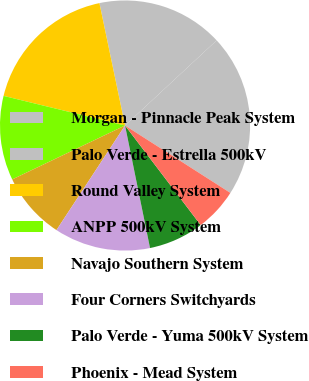<chart> <loc_0><loc_0><loc_500><loc_500><pie_chart><fcel>Morgan - Pinnacle Peak System<fcel>Palo Verde - Estrella 500kV<fcel>Round Valley System<fcel>ANPP 500kV System<fcel>Navajo Southern System<fcel>Four Corners Switchyards<fcel>Palo Verde - Yuma 500kV System<fcel>Phoenix - Mead System<nl><fcel>20.98%<fcel>16.37%<fcel>17.91%<fcel>10.9%<fcel>8.67%<fcel>12.44%<fcel>7.14%<fcel>5.6%<nl></chart> 